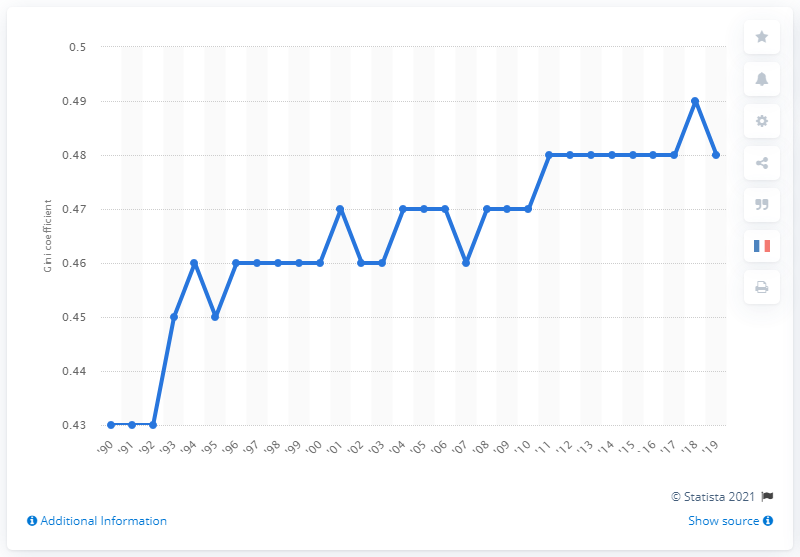Indicate a few pertinent items in this graphic. In 1990, the Gini coefficient for household income distribution was 0.43, indicating a moderate level of income inequality in the population. The Gini coefficient for household income distribution in the United States in 2019 was 0.48, indicating a moderate level of income inequality. 